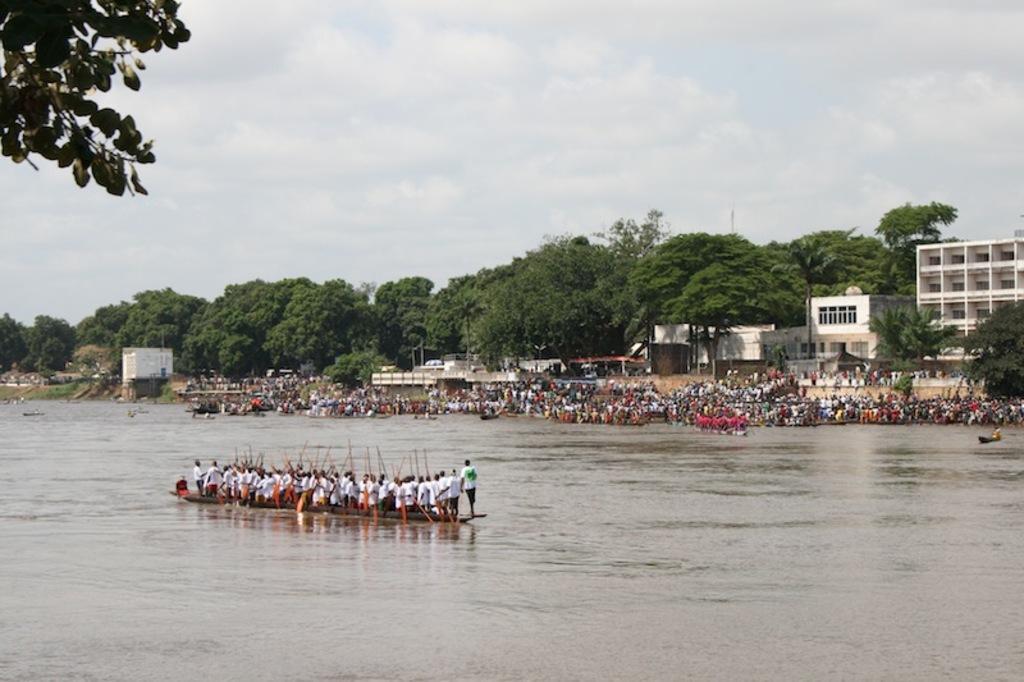Please provide a concise description of this image. In this picture there are group of people standing on the boat and there is a boat on the water. At the back there are boats and there are group of people and there are buildings and trees. At the top there is sky and there are clouds. At the bottom there is water. 